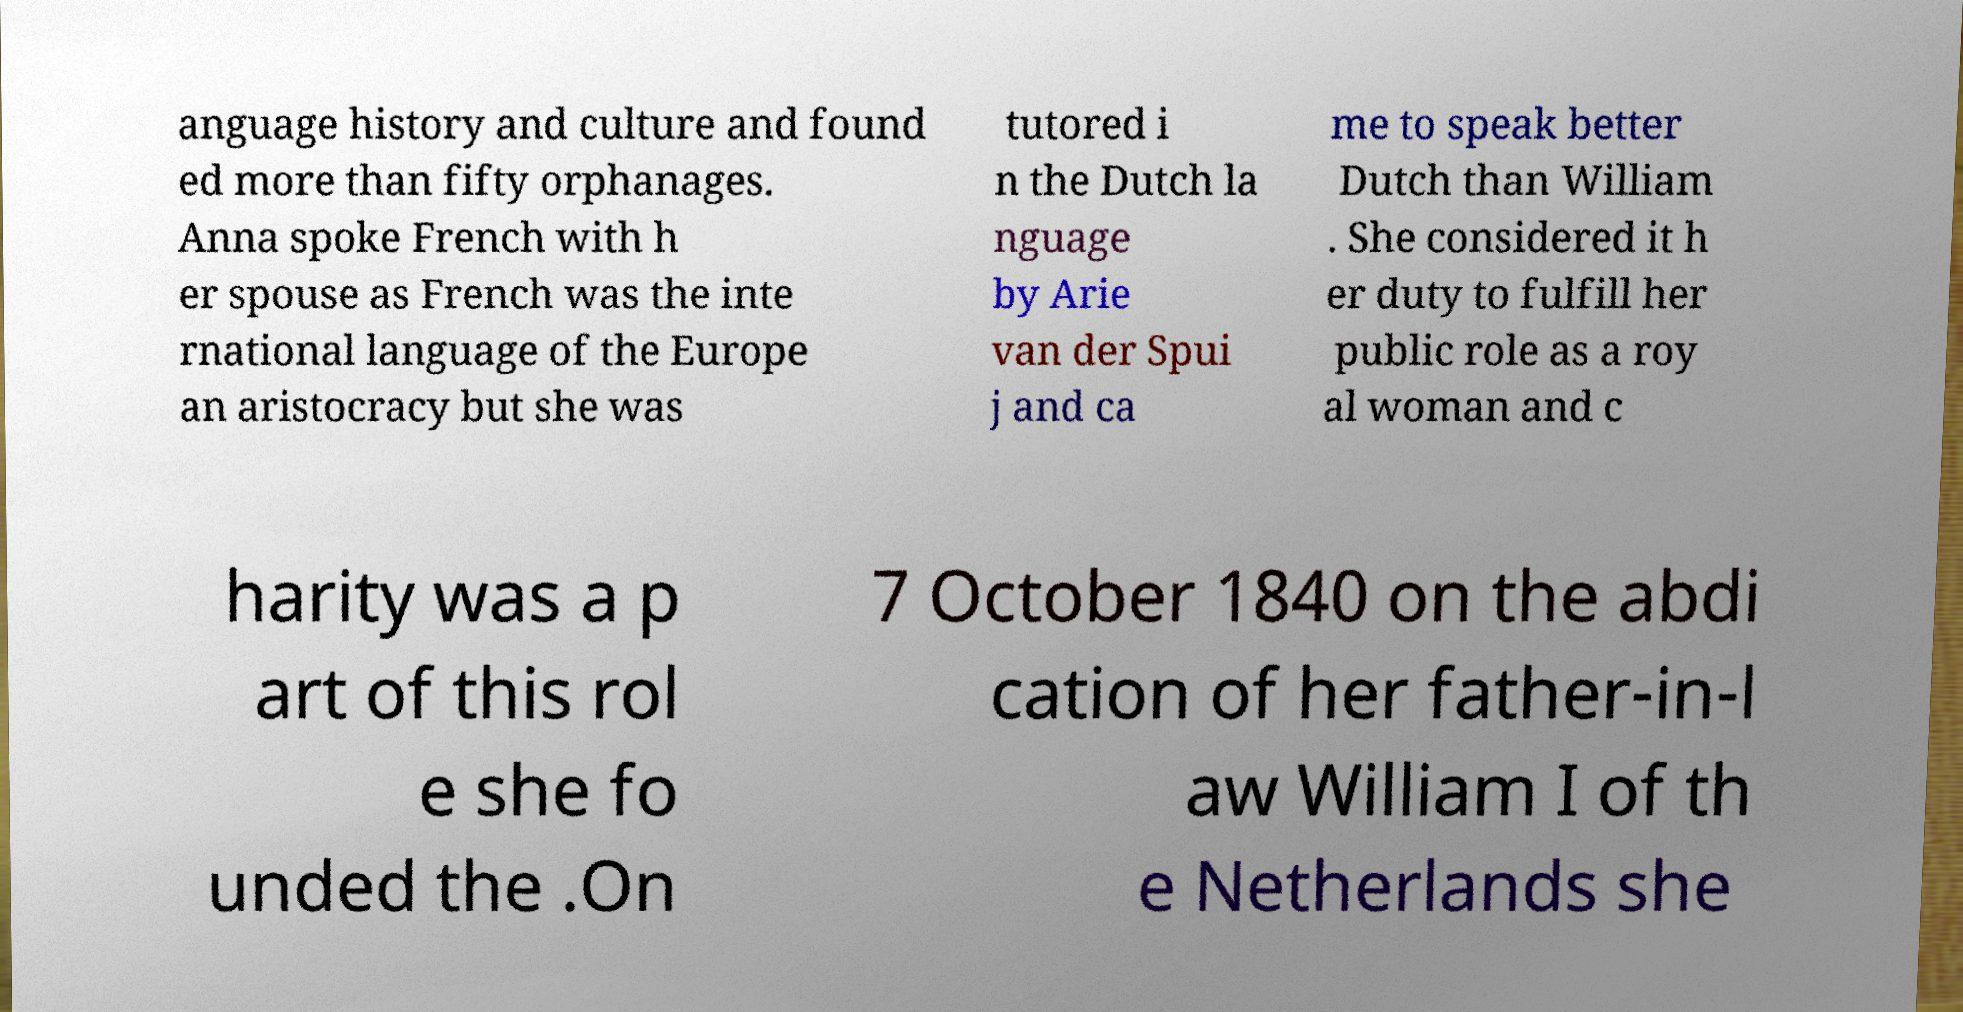Can you read and provide the text displayed in the image?This photo seems to have some interesting text. Can you extract and type it out for me? anguage history and culture and found ed more than fifty orphanages. Anna spoke French with h er spouse as French was the inte rnational language of the Europe an aristocracy but she was tutored i n the Dutch la nguage by Arie van der Spui j and ca me to speak better Dutch than William . She considered it h er duty to fulfill her public role as a roy al woman and c harity was a p art of this rol e she fo unded the .On 7 October 1840 on the abdi cation of her father-in-l aw William I of th e Netherlands she 